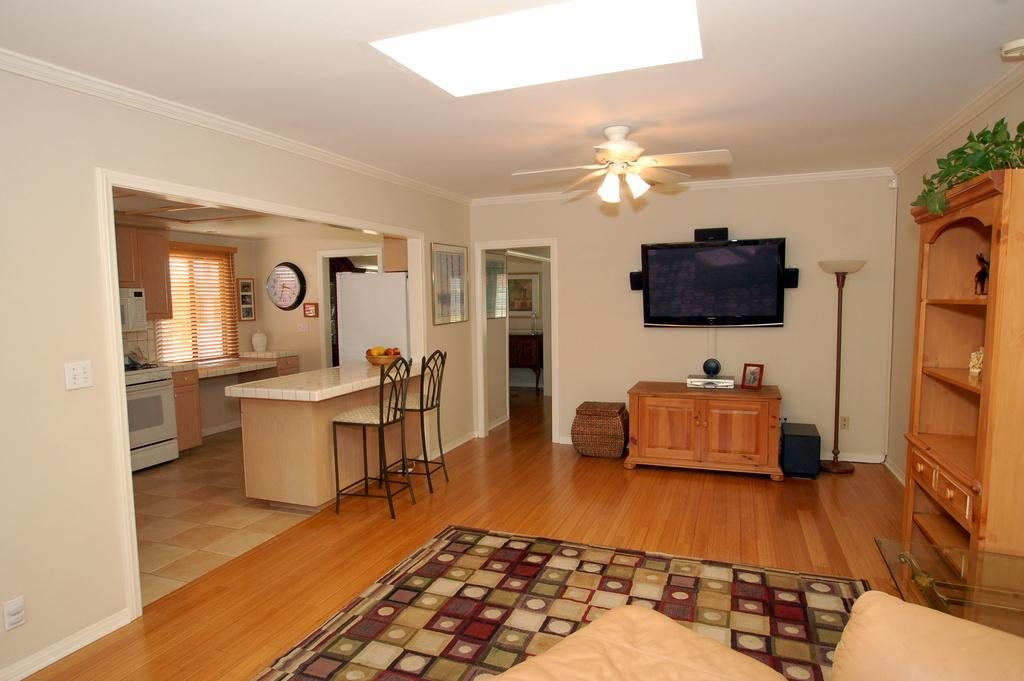Where is the image taken? The image is inside a room. What electronic device can be seen in the room? There is a television in the room. What type of furniture is present in the room? There is a table and chairs in the room. What storage unit is in the room? There is a cupboard in the room. What device is used for ventilation in the room? There is a ceiling fan in the room. What time-keeping device is on the wall in the room? There is a clock on the wall in the room. What type of lighting is in the room? There is a lamp in the room. What type of drainage system is visible in the room? There is no drainage system visible in the room; the image is taken inside a room with various objects and furniture. 